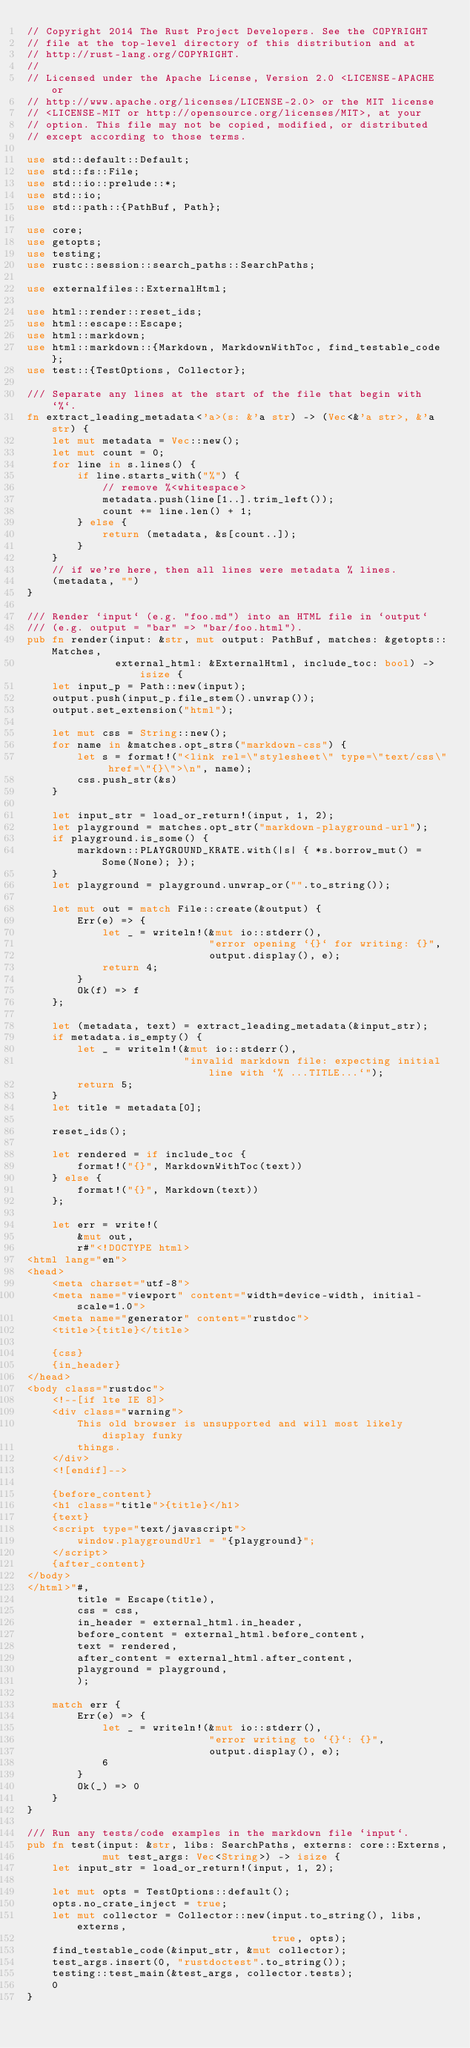<code> <loc_0><loc_0><loc_500><loc_500><_Rust_>// Copyright 2014 The Rust Project Developers. See the COPYRIGHT
// file at the top-level directory of this distribution and at
// http://rust-lang.org/COPYRIGHT.
//
// Licensed under the Apache License, Version 2.0 <LICENSE-APACHE or
// http://www.apache.org/licenses/LICENSE-2.0> or the MIT license
// <LICENSE-MIT or http://opensource.org/licenses/MIT>, at your
// option. This file may not be copied, modified, or distributed
// except according to those terms.

use std::default::Default;
use std::fs::File;
use std::io::prelude::*;
use std::io;
use std::path::{PathBuf, Path};

use core;
use getopts;
use testing;
use rustc::session::search_paths::SearchPaths;

use externalfiles::ExternalHtml;

use html::render::reset_ids;
use html::escape::Escape;
use html::markdown;
use html::markdown::{Markdown, MarkdownWithToc, find_testable_code};
use test::{TestOptions, Collector};

/// Separate any lines at the start of the file that begin with `%`.
fn extract_leading_metadata<'a>(s: &'a str) -> (Vec<&'a str>, &'a str) {
    let mut metadata = Vec::new();
    let mut count = 0;
    for line in s.lines() {
        if line.starts_with("%") {
            // remove %<whitespace>
            metadata.push(line[1..].trim_left());
            count += line.len() + 1;
        } else {
            return (metadata, &s[count..]);
        }
    }
    // if we're here, then all lines were metadata % lines.
    (metadata, "")
}

/// Render `input` (e.g. "foo.md") into an HTML file in `output`
/// (e.g. output = "bar" => "bar/foo.html").
pub fn render(input: &str, mut output: PathBuf, matches: &getopts::Matches,
              external_html: &ExternalHtml, include_toc: bool) -> isize {
    let input_p = Path::new(input);
    output.push(input_p.file_stem().unwrap());
    output.set_extension("html");

    let mut css = String::new();
    for name in &matches.opt_strs("markdown-css") {
        let s = format!("<link rel=\"stylesheet\" type=\"text/css\" href=\"{}\">\n", name);
        css.push_str(&s)
    }

    let input_str = load_or_return!(input, 1, 2);
    let playground = matches.opt_str("markdown-playground-url");
    if playground.is_some() {
        markdown::PLAYGROUND_KRATE.with(|s| { *s.borrow_mut() = Some(None); });
    }
    let playground = playground.unwrap_or("".to_string());

    let mut out = match File::create(&output) {
        Err(e) => {
            let _ = writeln!(&mut io::stderr(),
                             "error opening `{}` for writing: {}",
                             output.display(), e);
            return 4;
        }
        Ok(f) => f
    };

    let (metadata, text) = extract_leading_metadata(&input_str);
    if metadata.is_empty() {
        let _ = writeln!(&mut io::stderr(),
                         "invalid markdown file: expecting initial line with `% ...TITLE...`");
        return 5;
    }
    let title = metadata[0];

    reset_ids();

    let rendered = if include_toc {
        format!("{}", MarkdownWithToc(text))
    } else {
        format!("{}", Markdown(text))
    };

    let err = write!(
        &mut out,
        r#"<!DOCTYPE html>
<html lang="en">
<head>
    <meta charset="utf-8">
    <meta name="viewport" content="width=device-width, initial-scale=1.0">
    <meta name="generator" content="rustdoc">
    <title>{title}</title>

    {css}
    {in_header}
</head>
<body class="rustdoc">
    <!--[if lte IE 8]>
    <div class="warning">
        This old browser is unsupported and will most likely display funky
        things.
    </div>
    <![endif]-->

    {before_content}
    <h1 class="title">{title}</h1>
    {text}
    <script type="text/javascript">
        window.playgroundUrl = "{playground}";
    </script>
    {after_content}
</body>
</html>"#,
        title = Escape(title),
        css = css,
        in_header = external_html.in_header,
        before_content = external_html.before_content,
        text = rendered,
        after_content = external_html.after_content,
        playground = playground,
        );

    match err {
        Err(e) => {
            let _ = writeln!(&mut io::stderr(),
                             "error writing to `{}`: {}",
                             output.display(), e);
            6
        }
        Ok(_) => 0
    }
}

/// Run any tests/code examples in the markdown file `input`.
pub fn test(input: &str, libs: SearchPaths, externs: core::Externs,
            mut test_args: Vec<String>) -> isize {
    let input_str = load_or_return!(input, 1, 2);

    let mut opts = TestOptions::default();
    opts.no_crate_inject = true;
    let mut collector = Collector::new(input.to_string(), libs, externs,
                                       true, opts);
    find_testable_code(&input_str, &mut collector);
    test_args.insert(0, "rustdoctest".to_string());
    testing::test_main(&test_args, collector.tests);
    0
}
</code> 